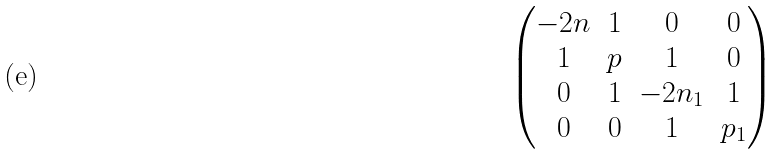<formula> <loc_0><loc_0><loc_500><loc_500>\begin{pmatrix} - 2 n & 1 & 0 & 0 \\ 1 & p & 1 & 0 \\ 0 & 1 & - 2 n _ { 1 } & 1 \\ 0 & 0 & 1 & p _ { 1 } \end{pmatrix}</formula> 